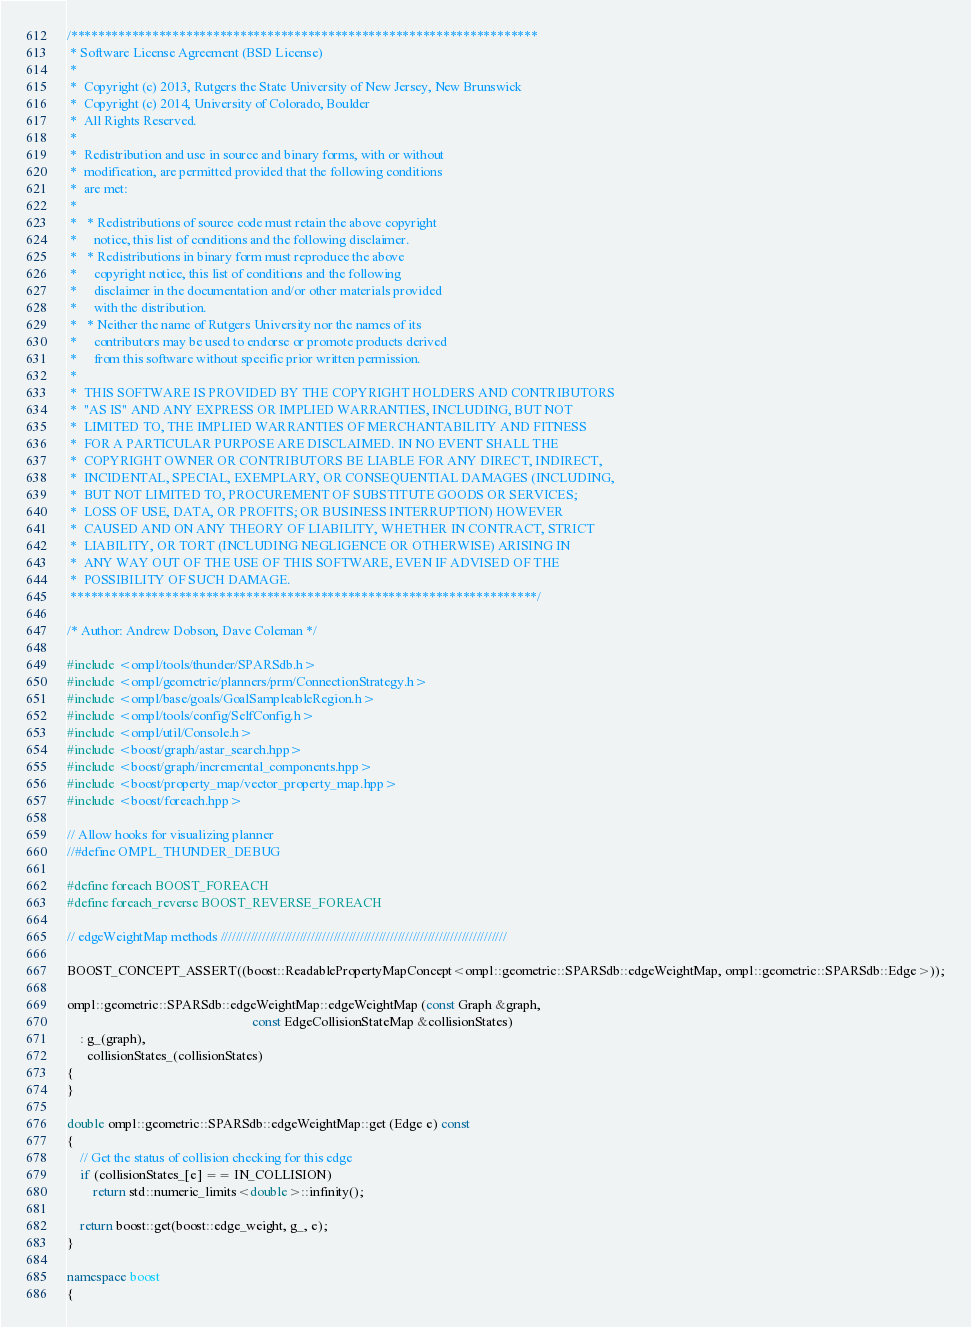<code> <loc_0><loc_0><loc_500><loc_500><_C++_>/*********************************************************************
 * Software License Agreement (BSD License)
 *
 *  Copyright (c) 2013, Rutgers the State University of New Jersey, New Brunswick
 *  Copyright (c) 2014, University of Colorado, Boulder
 *  All Rights Reserved.
 *
 *  Redistribution and use in source and binary forms, with or without
 *  modification, are permitted provided that the following conditions
 *  are met:
 *
 *   * Redistributions of source code must retain the above copyright
 *     notice, this list of conditions and the following disclaimer.
 *   * Redistributions in binary form must reproduce the above
 *     copyright notice, this list of conditions and the following
 *     disclaimer in the documentation and/or other materials provided
 *     with the distribution.
 *   * Neither the name of Rutgers University nor the names of its
 *     contributors may be used to endorse or promote products derived
 *     from this software without specific prior written permission.
 *
 *  THIS SOFTWARE IS PROVIDED BY THE COPYRIGHT HOLDERS AND CONTRIBUTORS
 *  "AS IS" AND ANY EXPRESS OR IMPLIED WARRANTIES, INCLUDING, BUT NOT
 *  LIMITED TO, THE IMPLIED WARRANTIES OF MERCHANTABILITY AND FITNESS
 *  FOR A PARTICULAR PURPOSE ARE DISCLAIMED. IN NO EVENT SHALL THE
 *  COPYRIGHT OWNER OR CONTRIBUTORS BE LIABLE FOR ANY DIRECT, INDIRECT,
 *  INCIDENTAL, SPECIAL, EXEMPLARY, OR CONSEQUENTIAL DAMAGES (INCLUDING,
 *  BUT NOT LIMITED TO, PROCUREMENT OF SUBSTITUTE GOODS OR SERVICES;
 *  LOSS OF USE, DATA, OR PROFITS; OR BUSINESS INTERRUPTION) HOWEVER
 *  CAUSED AND ON ANY THEORY OF LIABILITY, WHETHER IN CONTRACT, STRICT
 *  LIABILITY, OR TORT (INCLUDING NEGLIGENCE OR OTHERWISE) ARISING IN
 *  ANY WAY OUT OF THE USE OF THIS SOFTWARE, EVEN IF ADVISED OF THE
 *  POSSIBILITY OF SUCH DAMAGE.
 *********************************************************************/

/* Author: Andrew Dobson, Dave Coleman */

#include <ompl/tools/thunder/SPARSdb.h>
#include <ompl/geometric/planners/prm/ConnectionStrategy.h>
#include <ompl/base/goals/GoalSampleableRegion.h>
#include <ompl/tools/config/SelfConfig.h>
#include <ompl/util/Console.h>
#include <boost/graph/astar_search.hpp>
#include <boost/graph/incremental_components.hpp>
#include <boost/property_map/vector_property_map.hpp>
#include <boost/foreach.hpp>

// Allow hooks for visualizing planner
//#define OMPL_THUNDER_DEBUG

#define foreach BOOST_FOREACH
#define foreach_reverse BOOST_REVERSE_FOREACH

// edgeWeightMap methods ////////////////////////////////////////////////////////////////////////////

BOOST_CONCEPT_ASSERT((boost::ReadablePropertyMapConcept<ompl::geometric::SPARSdb::edgeWeightMap, ompl::geometric::SPARSdb::Edge>));

ompl::geometric::SPARSdb::edgeWeightMap::edgeWeightMap (const Graph &graph,
                                                        const EdgeCollisionStateMap &collisionStates)
    : g_(graph),
      collisionStates_(collisionStates)
{
}

double ompl::geometric::SPARSdb::edgeWeightMap::get (Edge e) const
{
    // Get the status of collision checking for this edge
    if (collisionStates_[e] == IN_COLLISION)
        return std::numeric_limits<double>::infinity();

    return boost::get(boost::edge_weight, g_, e);
}

namespace boost
{</code> 